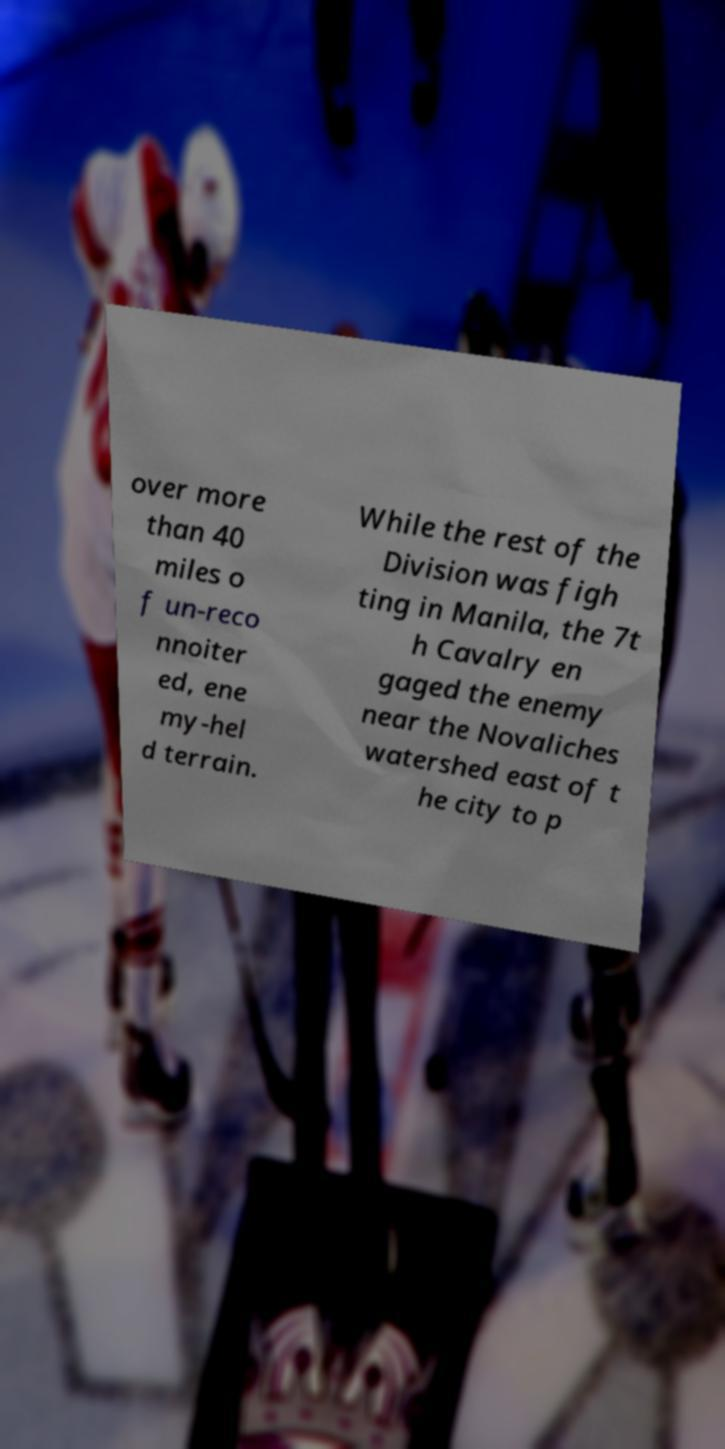Please read and relay the text visible in this image. What does it say? over more than 40 miles o f un-reco nnoiter ed, ene my-hel d terrain. While the rest of the Division was figh ting in Manila, the 7t h Cavalry en gaged the enemy near the Novaliches watershed east of t he city to p 